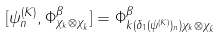<formula> <loc_0><loc_0><loc_500><loc_500>[ \psi _ { n } ^ { ( K ) } , \Phi _ { \chi _ { k } \otimes \chi _ { \bar { k } } } ^ { \beta } ] = \Phi _ { k ( \delta _ { 1 } ( \psi ^ { ( K ) } ) _ { n } ) \chi _ { k } \otimes \chi _ { \bar { k } } } ^ { \beta }</formula> 